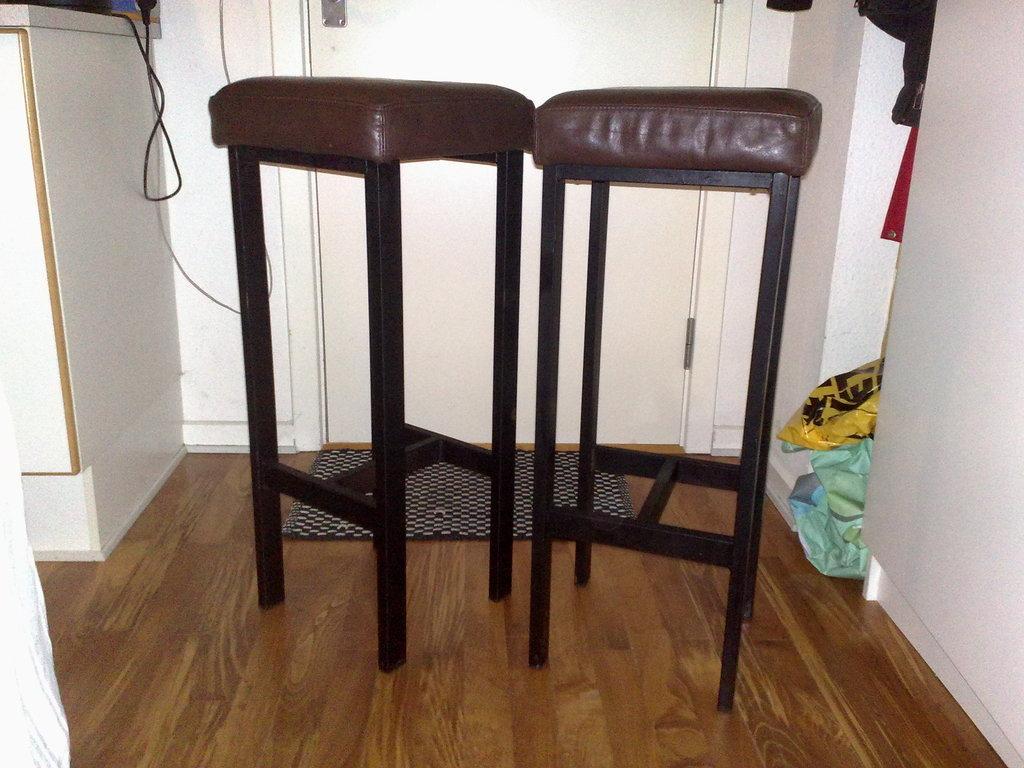Describe this image in one or two sentences. In this image I can see two stools on the floor. In the background I can see a door, cabinet and a wire. This image is taken may be in a room. 